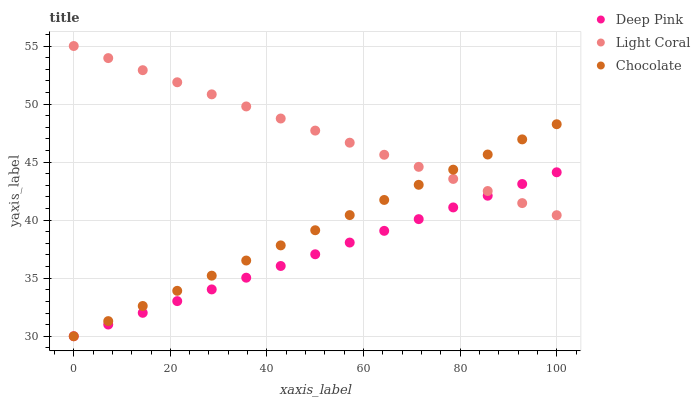Does Deep Pink have the minimum area under the curve?
Answer yes or no. Yes. Does Light Coral have the maximum area under the curve?
Answer yes or no. Yes. Does Chocolate have the minimum area under the curve?
Answer yes or no. No. Does Chocolate have the maximum area under the curve?
Answer yes or no. No. Is Chocolate the smoothest?
Answer yes or no. Yes. Is Deep Pink the roughest?
Answer yes or no. Yes. Is Deep Pink the smoothest?
Answer yes or no. No. Is Chocolate the roughest?
Answer yes or no. No. Does Deep Pink have the lowest value?
Answer yes or no. Yes. Does Light Coral have the highest value?
Answer yes or no. Yes. Does Chocolate have the highest value?
Answer yes or no. No. Does Light Coral intersect Chocolate?
Answer yes or no. Yes. Is Light Coral less than Chocolate?
Answer yes or no. No. Is Light Coral greater than Chocolate?
Answer yes or no. No. 